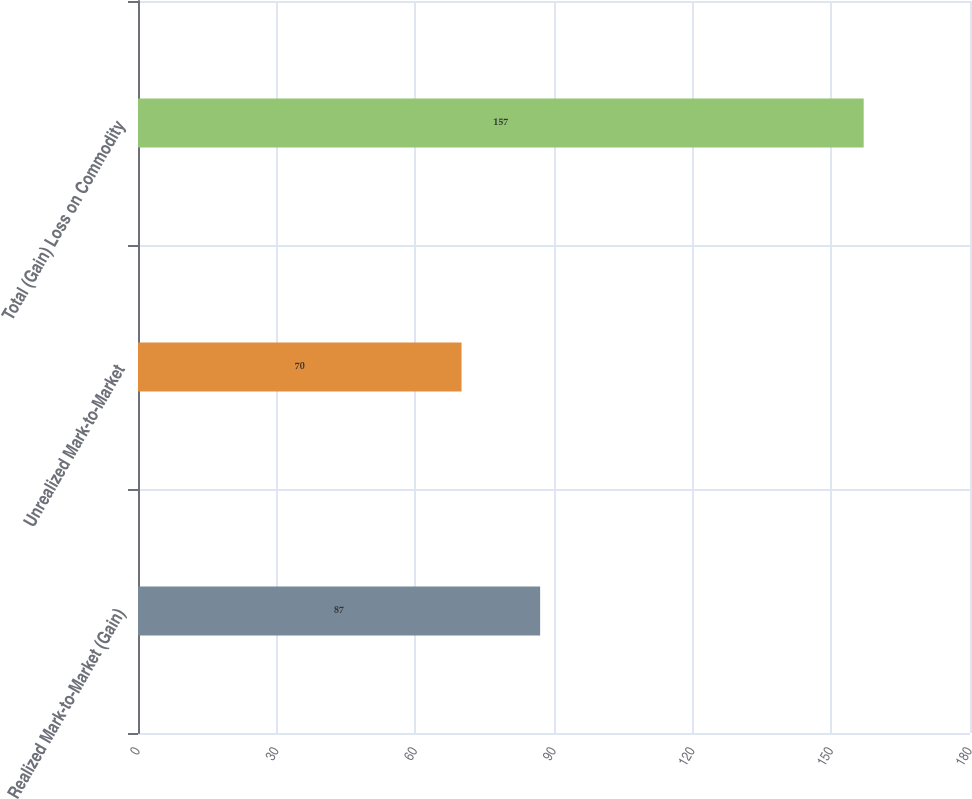Convert chart. <chart><loc_0><loc_0><loc_500><loc_500><bar_chart><fcel>Realized Mark-to-Market (Gain)<fcel>Unrealized Mark-to-Market<fcel>Total (Gain) Loss on Commodity<nl><fcel>87<fcel>70<fcel>157<nl></chart> 